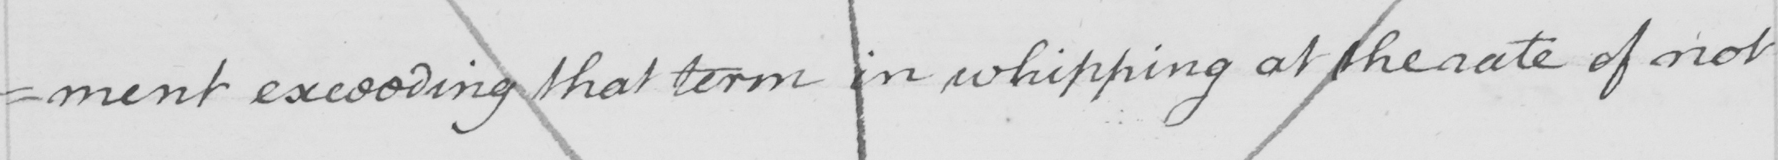Can you tell me what this handwritten text says? =ment exceeding that term in whipping at the rate of not 